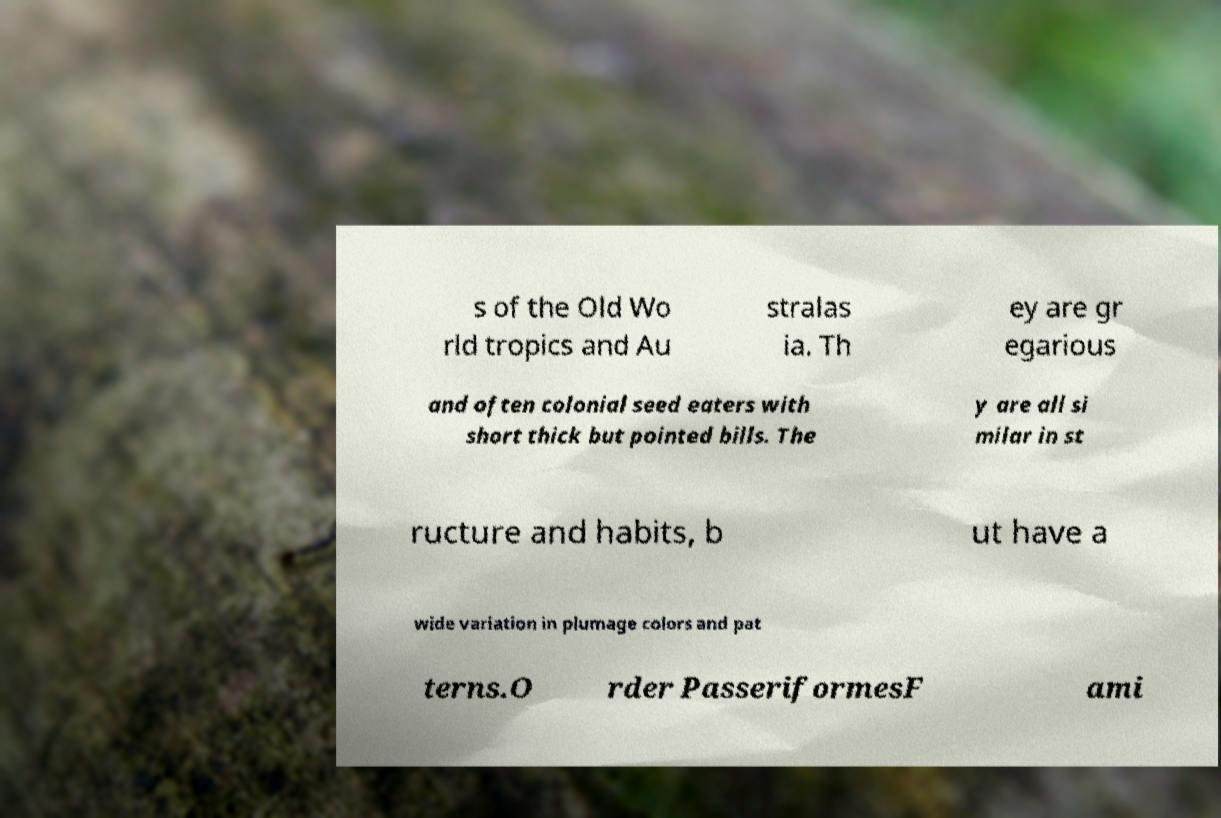Please identify and transcribe the text found in this image. s of the Old Wo rld tropics and Au stralas ia. Th ey are gr egarious and often colonial seed eaters with short thick but pointed bills. The y are all si milar in st ructure and habits, b ut have a wide variation in plumage colors and pat terns.O rder PasseriformesF ami 